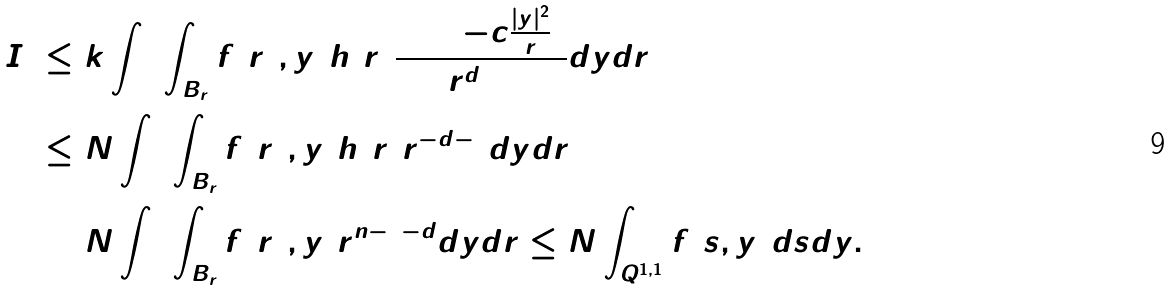<formula> <loc_0><loc_0><loc_500><loc_500>I _ { 2 } & \leq k \int _ { 0 } ^ { 1 } \int _ { B _ { r } } f ( r ^ { 2 } , y ) h ( r ) \frac { \exp ( - c \frac { | y | ^ { 2 } } { r } ) } { r ^ { d + 1 } } d y d r \\ & \leq N \int _ { 0 } ^ { 1 } \int _ { B _ { r } } f ( r ^ { 2 } , y ) h ( r ) r ^ { - d - 1 } d y d r \\ & = N \int _ { 0 } ^ { 1 } \int _ { B _ { r } } f ( r ^ { 2 } , y ) r ^ { n - 2 - d } d y d r \leq N \int _ { Q ^ { 1 , 1 } } f ( s , y ) d s d y .</formula> 